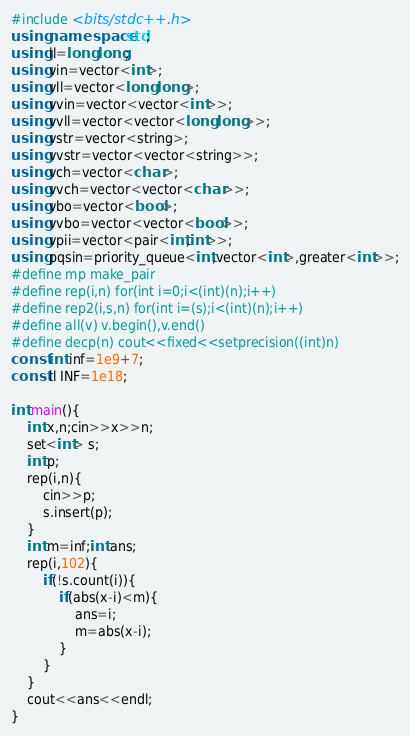<code> <loc_0><loc_0><loc_500><loc_500><_C++_>#include <bits/stdc++.h>
using namespace std;
using ll=long long;
using vin=vector<int>;
using vll=vector<long long>;
using vvin=vector<vector<int>>;
using vvll=vector<vector<long long>>;
using vstr=vector<string>;
using vvstr=vector<vector<string>>;
using vch=vector<char>;
using vvch=vector<vector<char>>;
using vbo=vector<bool>;
using vvbo=vector<vector<bool>>;
using vpii=vector<pair<int,int>>;
using pqsin=priority_queue<int,vector<int>,greater<int>>;
#define mp make_pair
#define rep(i,n) for(int i=0;i<(int)(n);i++)
#define rep2(i,s,n) for(int i=(s);i<(int)(n);i++)
#define all(v) v.begin(),v.end()
#define decp(n) cout<<fixed<<setprecision((int)n)
const int inf=1e9+7;
const ll INF=1e18;

int main(){
    int x,n;cin>>x>>n;
    set<int> s;
    int p;
    rep(i,n){
        cin>>p;
        s.insert(p);
    }
    int m=inf;int ans;
    rep(i,102){
        if(!s.count(i)){
            if(abs(x-i)<m){
                ans=i;
                m=abs(x-i);
            }
        }
    }
    cout<<ans<<endl;
}</code> 